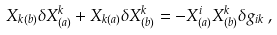Convert formula to latex. <formula><loc_0><loc_0><loc_500><loc_500>X _ { k ( b ) } \delta X ^ { k } _ { ( a ) } + X _ { k ( a ) } \delta X ^ { k } _ { ( b ) } = - X ^ { i } _ { ( a ) } X ^ { k } _ { ( b ) } \delta g _ { i k } \, ,</formula> 